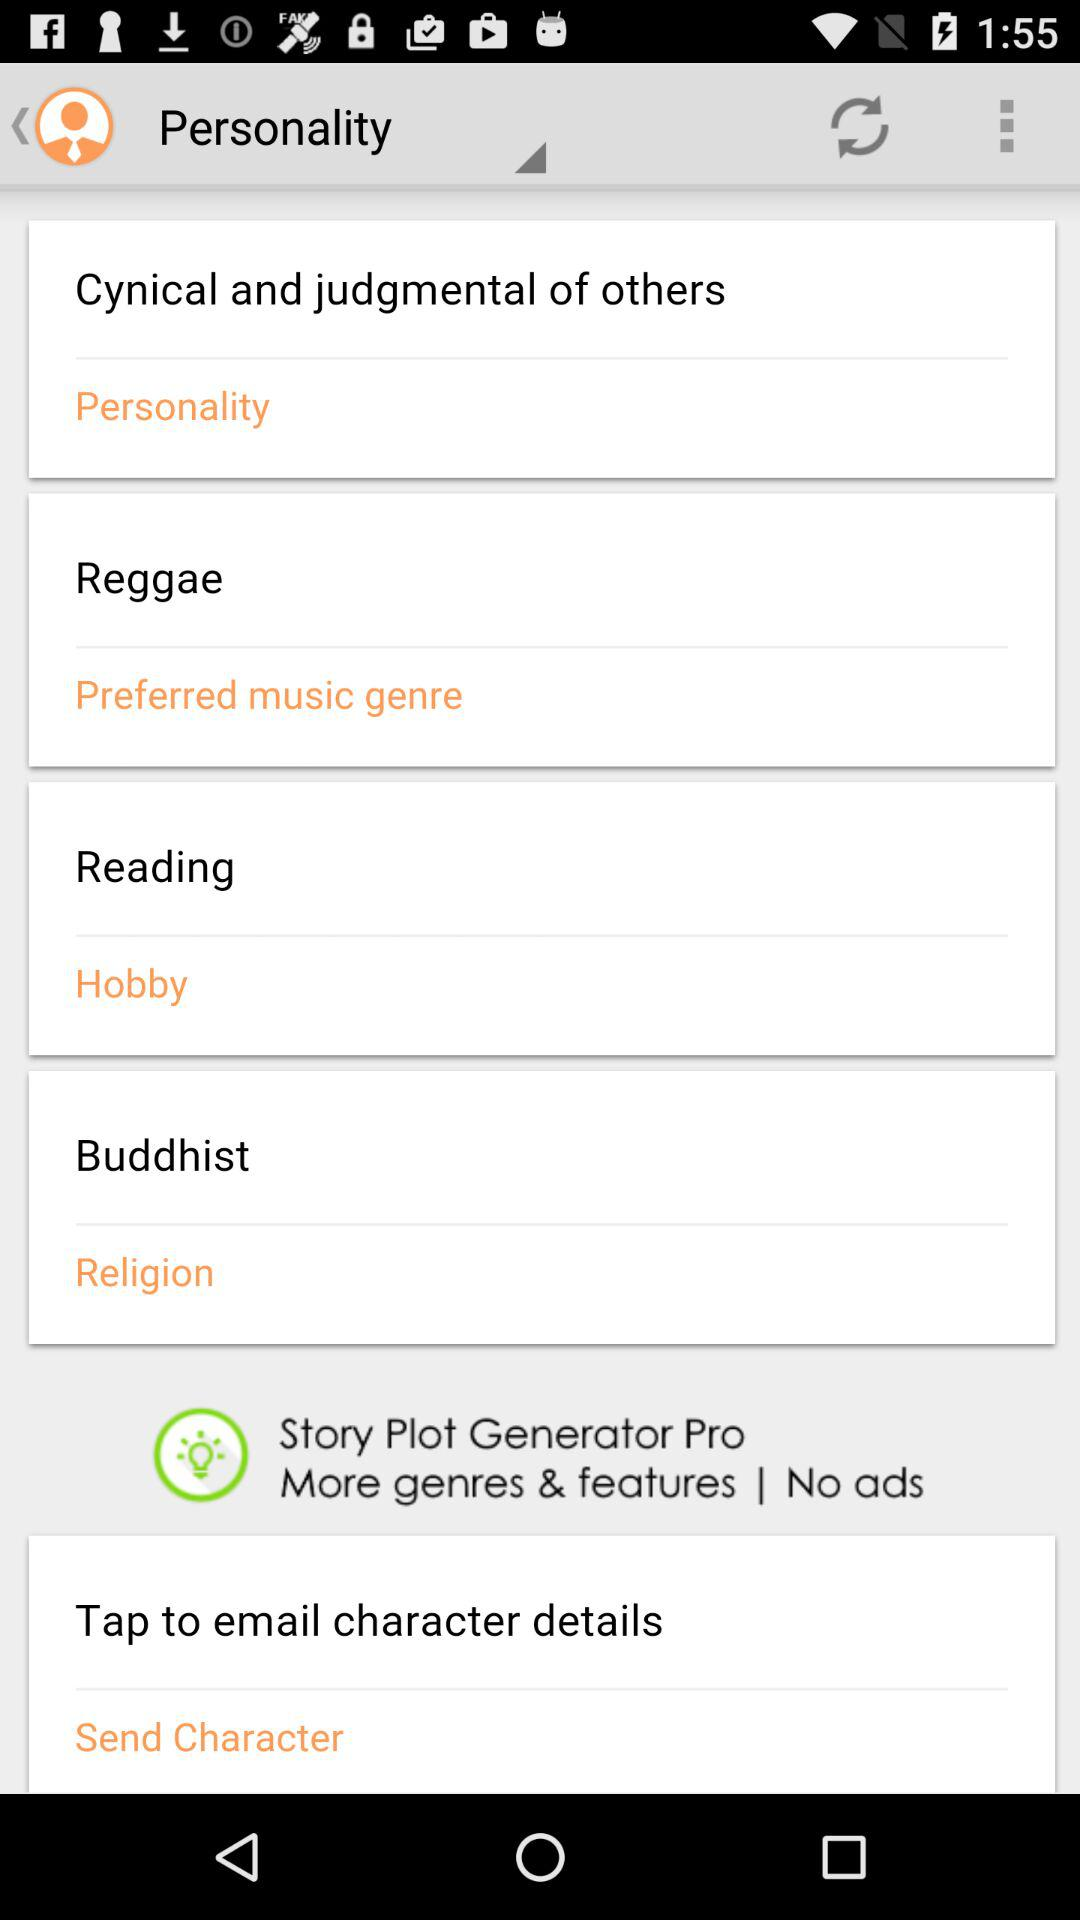What is the selected hobby? The selected hobby is reading. 